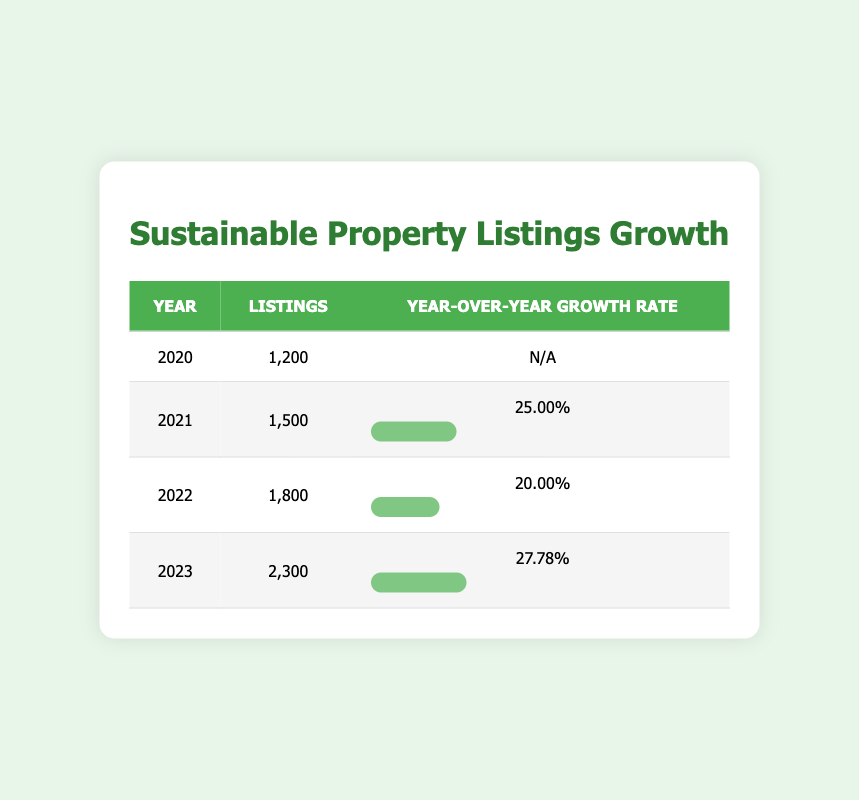What was the year with the highest number of sustainable property listings? From the table, we look at the 'Listings' column for all years. The highest value, 2300, is found in the year 2023.
Answer: 2023 What was the year-over-year growth rate for 2022? Referring to the 'Year-over-Year Growth Rate' column, the value in 2022 is 20.00%.
Answer: 20.00% Did the number of sustainable property listings increase every year from 2020 to 2023? By examining the 'Listings' column, we see that the numbers increased consistently from 1200 in 2020 to 2300 in 2023, confirming the increase each year.
Answer: Yes What is the average year-over-year growth rate from 2021 to 2023? The growth rates for these years are 25.00% (2021), 20.00% (2022), and 27.78% (2023). Adding these gives 25.00 + 20.00 + 27.78 = 72.78%. Dividing by 3 years, the average is 72.78/3 = 24.26%.
Answer: 24.26% What was the total number of property listings from 2021 to 2023 combined? We sum the listings for each year: 1500 (2021) + 1800 (2022) + 2300 (2023) = 1500 + 1800 + 2300 = 5600.
Answer: 5600 